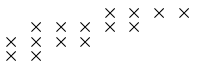<formula> <loc_0><loc_0><loc_500><loc_500>\begin{smallmatrix} & & & & \times & \times & \times & \times \\ & \times & \times & \times & \times & \times \\ \times & \times & \times & \times \\ \times & \times \end{smallmatrix}</formula> 